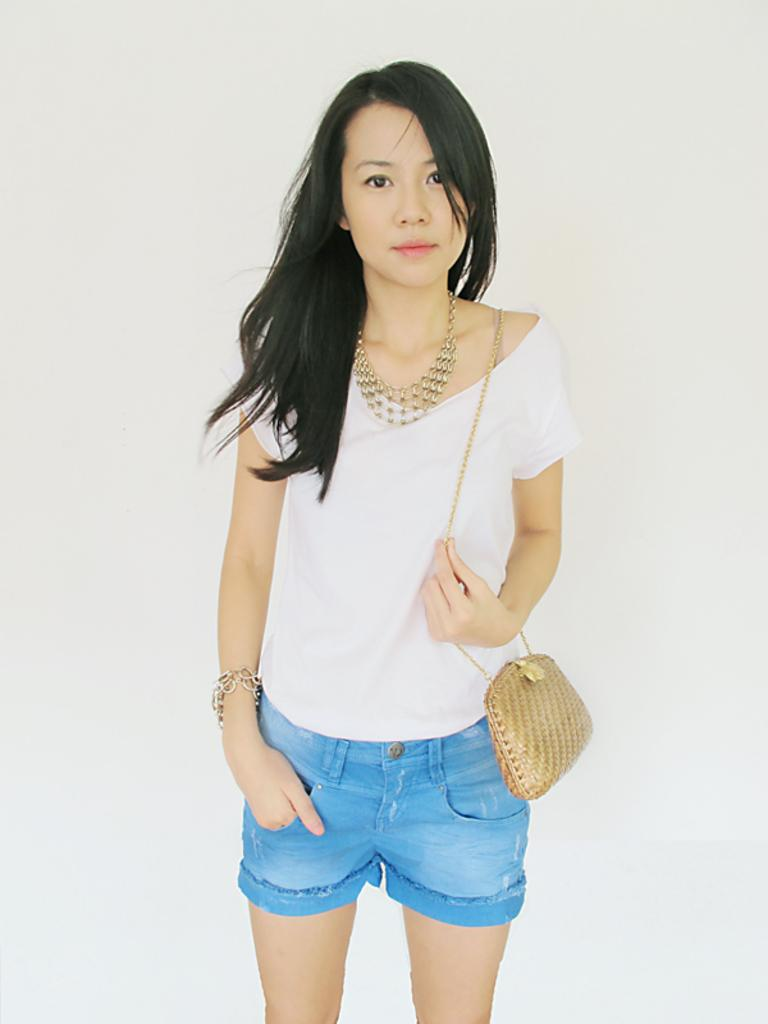What is the main subject of the image? There is a person standing in the image. What is the person wearing? The person is wearing a white and blue color dress. What else is the person carrying in the image? The person is carrying a cream color bag. What is the color of the background in the image? The background of the image is white. How many children are playing with the clam in the image? There are no children or clams present in the image. 